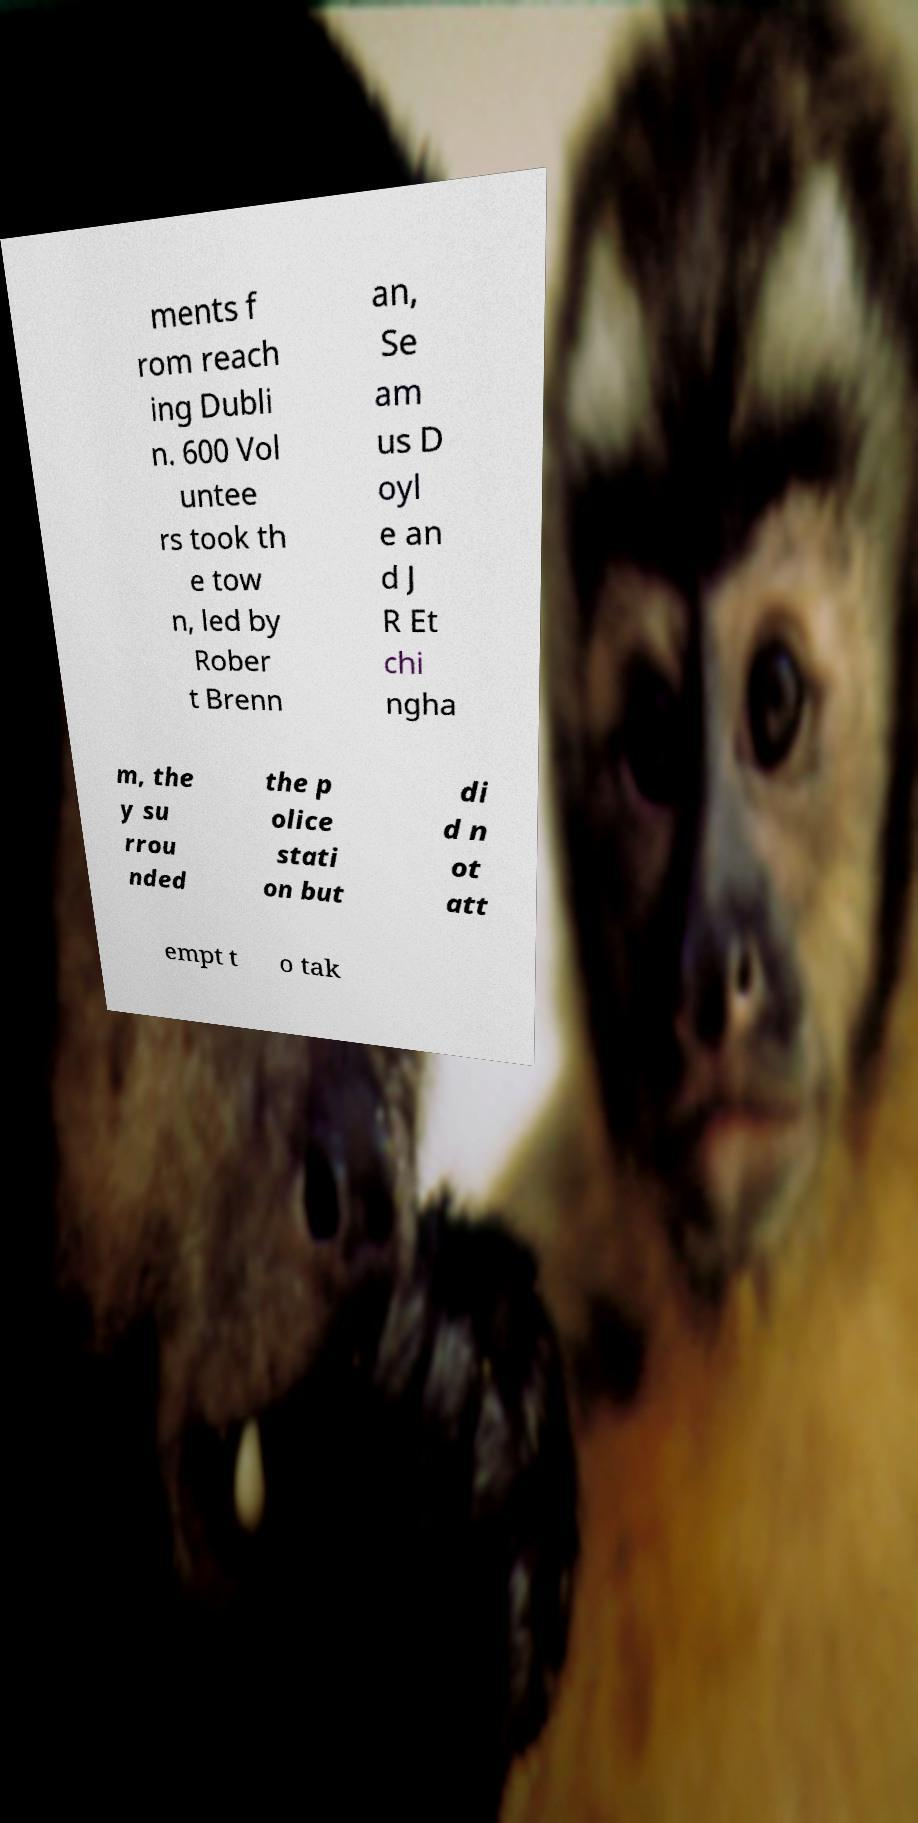Can you accurately transcribe the text from the provided image for me? ments f rom reach ing Dubli n. 600 Vol untee rs took th e tow n, led by Rober t Brenn an, Se am us D oyl e an d J R Et chi ngha m, the y su rrou nded the p olice stati on but di d n ot att empt t o tak 